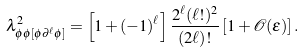Convert formula to latex. <formula><loc_0><loc_0><loc_500><loc_500>\lambda _ { \phi \phi [ \phi \partial ^ { \ell } \phi ] } ^ { 2 } = \left [ 1 + ( - 1 ) ^ { \ell } \right ] \frac { 2 ^ { \ell } ( \ell ! ) ^ { 2 } } { ( 2 \ell ) ! } \left [ 1 + \mathcal { O } ( \varepsilon ) \right ] .</formula> 